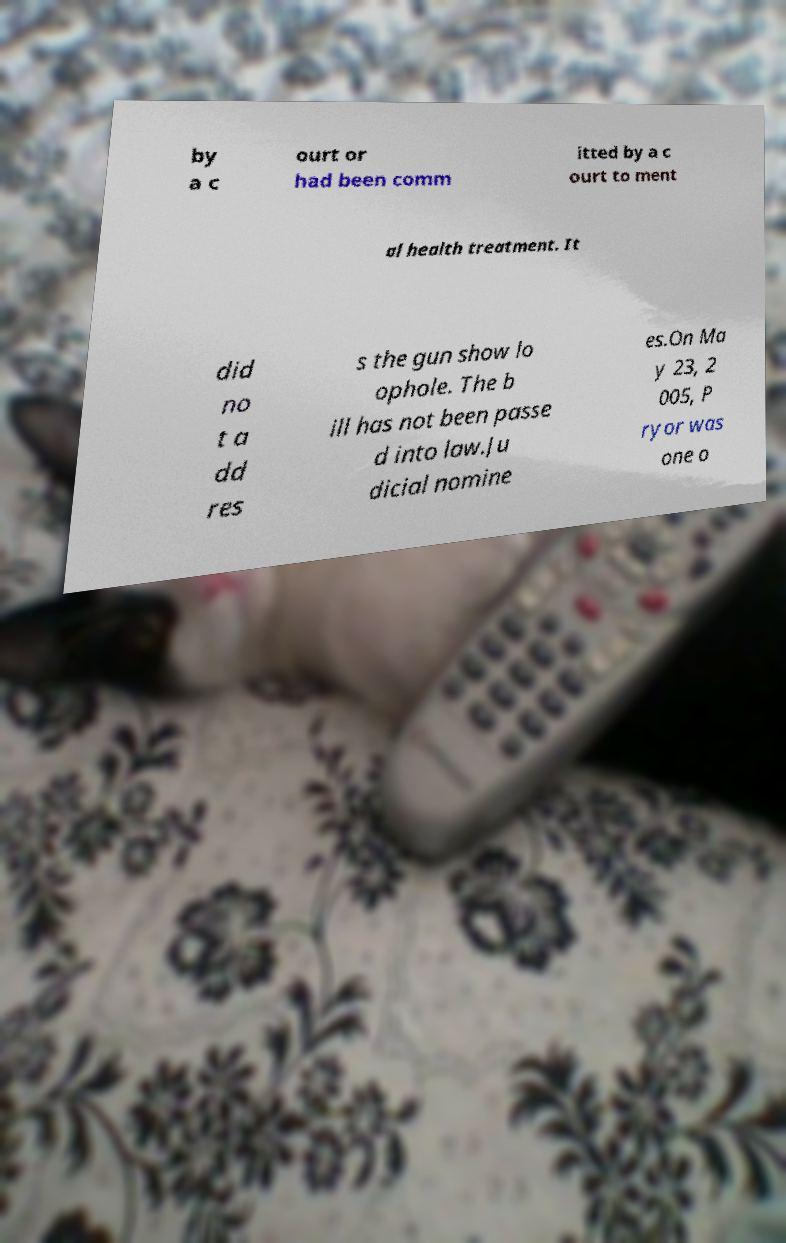What messages or text are displayed in this image? I need them in a readable, typed format. by a c ourt or had been comm itted by a c ourt to ment al health treatment. It did no t a dd res s the gun show lo ophole. The b ill has not been passe d into law.Ju dicial nomine es.On Ma y 23, 2 005, P ryor was one o 